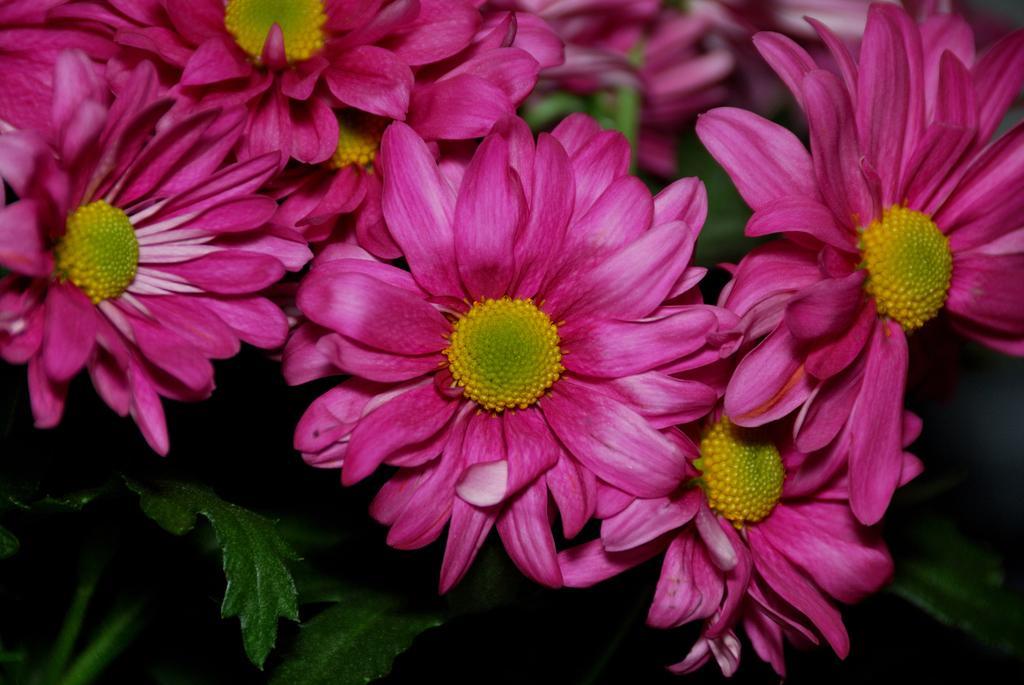In one or two sentences, can you explain what this image depicts? In this picture we can see flowers and in the background we can see leaves. 